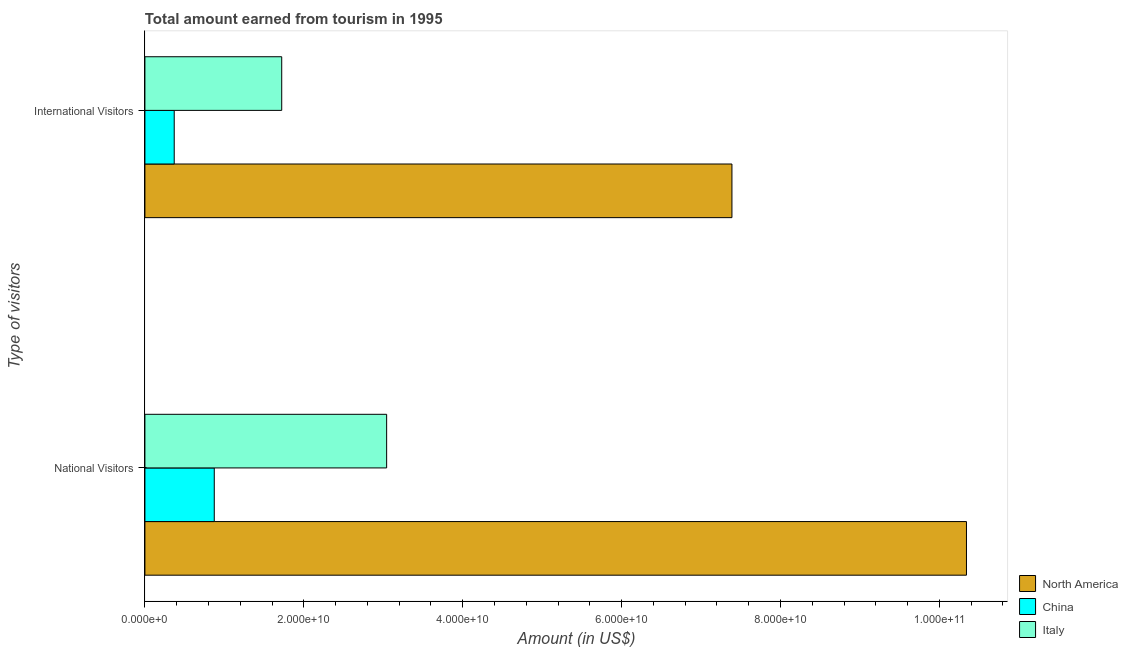How many groups of bars are there?
Ensure brevity in your answer.  2. Are the number of bars per tick equal to the number of legend labels?
Offer a very short reply. Yes. How many bars are there on the 2nd tick from the top?
Provide a succinct answer. 3. What is the label of the 1st group of bars from the top?
Ensure brevity in your answer.  International Visitors. What is the amount earned from international visitors in Italy?
Offer a very short reply. 1.72e+1. Across all countries, what is the maximum amount earned from national visitors?
Keep it short and to the point. 1.03e+11. Across all countries, what is the minimum amount earned from international visitors?
Your answer should be compact. 3.69e+09. What is the total amount earned from international visitors in the graph?
Provide a short and direct response. 9.48e+1. What is the difference between the amount earned from international visitors in North America and that in China?
Provide a succinct answer. 7.02e+1. What is the difference between the amount earned from international visitors in Italy and the amount earned from national visitors in China?
Your answer should be very brief. 8.49e+09. What is the average amount earned from international visitors per country?
Your response must be concise. 3.16e+1. What is the difference between the amount earned from international visitors and amount earned from national visitors in North America?
Your answer should be very brief. -2.95e+1. In how many countries, is the amount earned from international visitors greater than 32000000000 US$?
Give a very brief answer. 1. What is the ratio of the amount earned from international visitors in North America to that in China?
Keep it short and to the point. 20.03. Is the amount earned from international visitors in Italy less than that in North America?
Offer a very short reply. Yes. Are all the bars in the graph horizontal?
Keep it short and to the point. Yes. How many countries are there in the graph?
Provide a short and direct response. 3. What is the difference between two consecutive major ticks on the X-axis?
Ensure brevity in your answer.  2.00e+1. Are the values on the major ticks of X-axis written in scientific E-notation?
Your response must be concise. Yes. Does the graph contain any zero values?
Your response must be concise. No. Does the graph contain grids?
Your answer should be very brief. No. What is the title of the graph?
Keep it short and to the point. Total amount earned from tourism in 1995. What is the label or title of the Y-axis?
Ensure brevity in your answer.  Type of visitors. What is the Amount (in US$) in North America in National Visitors?
Your answer should be compact. 1.03e+11. What is the Amount (in US$) of China in National Visitors?
Your answer should be compact. 8.73e+09. What is the Amount (in US$) in Italy in National Visitors?
Provide a short and direct response. 3.04e+1. What is the Amount (in US$) in North America in International Visitors?
Ensure brevity in your answer.  7.39e+1. What is the Amount (in US$) in China in International Visitors?
Your response must be concise. 3.69e+09. What is the Amount (in US$) in Italy in International Visitors?
Offer a terse response. 1.72e+1. Across all Type of visitors, what is the maximum Amount (in US$) in North America?
Offer a terse response. 1.03e+11. Across all Type of visitors, what is the maximum Amount (in US$) in China?
Keep it short and to the point. 8.73e+09. Across all Type of visitors, what is the maximum Amount (in US$) in Italy?
Your response must be concise. 3.04e+1. Across all Type of visitors, what is the minimum Amount (in US$) of North America?
Offer a terse response. 7.39e+1. Across all Type of visitors, what is the minimum Amount (in US$) of China?
Keep it short and to the point. 3.69e+09. Across all Type of visitors, what is the minimum Amount (in US$) of Italy?
Offer a very short reply. 1.72e+1. What is the total Amount (in US$) in North America in the graph?
Ensure brevity in your answer.  1.77e+11. What is the total Amount (in US$) in China in the graph?
Offer a terse response. 1.24e+1. What is the total Amount (in US$) of Italy in the graph?
Provide a short and direct response. 4.76e+1. What is the difference between the Amount (in US$) in North America in National Visitors and that in International Visitors?
Your answer should be compact. 2.95e+1. What is the difference between the Amount (in US$) of China in National Visitors and that in International Visitors?
Give a very brief answer. 5.04e+09. What is the difference between the Amount (in US$) in Italy in National Visitors and that in International Visitors?
Give a very brief answer. 1.32e+1. What is the difference between the Amount (in US$) in North America in National Visitors and the Amount (in US$) in China in International Visitors?
Make the answer very short. 9.97e+1. What is the difference between the Amount (in US$) in North America in National Visitors and the Amount (in US$) in Italy in International Visitors?
Offer a terse response. 8.62e+1. What is the difference between the Amount (in US$) of China in National Visitors and the Amount (in US$) of Italy in International Visitors?
Offer a terse response. -8.49e+09. What is the average Amount (in US$) in North America per Type of visitors?
Your answer should be very brief. 8.86e+1. What is the average Amount (in US$) of China per Type of visitors?
Your response must be concise. 6.21e+09. What is the average Amount (in US$) of Italy per Type of visitors?
Your response must be concise. 2.38e+1. What is the difference between the Amount (in US$) of North America and Amount (in US$) of China in National Visitors?
Ensure brevity in your answer.  9.47e+1. What is the difference between the Amount (in US$) of North America and Amount (in US$) of Italy in National Visitors?
Offer a very short reply. 7.30e+1. What is the difference between the Amount (in US$) of China and Amount (in US$) of Italy in National Visitors?
Your answer should be compact. -2.17e+1. What is the difference between the Amount (in US$) in North America and Amount (in US$) in China in International Visitors?
Offer a very short reply. 7.02e+1. What is the difference between the Amount (in US$) of North America and Amount (in US$) of Italy in International Visitors?
Ensure brevity in your answer.  5.67e+1. What is the difference between the Amount (in US$) in China and Amount (in US$) in Italy in International Visitors?
Your response must be concise. -1.35e+1. What is the ratio of the Amount (in US$) of North America in National Visitors to that in International Visitors?
Your answer should be compact. 1.4. What is the ratio of the Amount (in US$) of China in National Visitors to that in International Visitors?
Your answer should be very brief. 2.37. What is the ratio of the Amount (in US$) in Italy in National Visitors to that in International Visitors?
Keep it short and to the point. 1.77. What is the difference between the highest and the second highest Amount (in US$) in North America?
Offer a terse response. 2.95e+1. What is the difference between the highest and the second highest Amount (in US$) in China?
Provide a succinct answer. 5.04e+09. What is the difference between the highest and the second highest Amount (in US$) of Italy?
Offer a terse response. 1.32e+1. What is the difference between the highest and the lowest Amount (in US$) of North America?
Give a very brief answer. 2.95e+1. What is the difference between the highest and the lowest Amount (in US$) of China?
Keep it short and to the point. 5.04e+09. What is the difference between the highest and the lowest Amount (in US$) in Italy?
Give a very brief answer. 1.32e+1. 